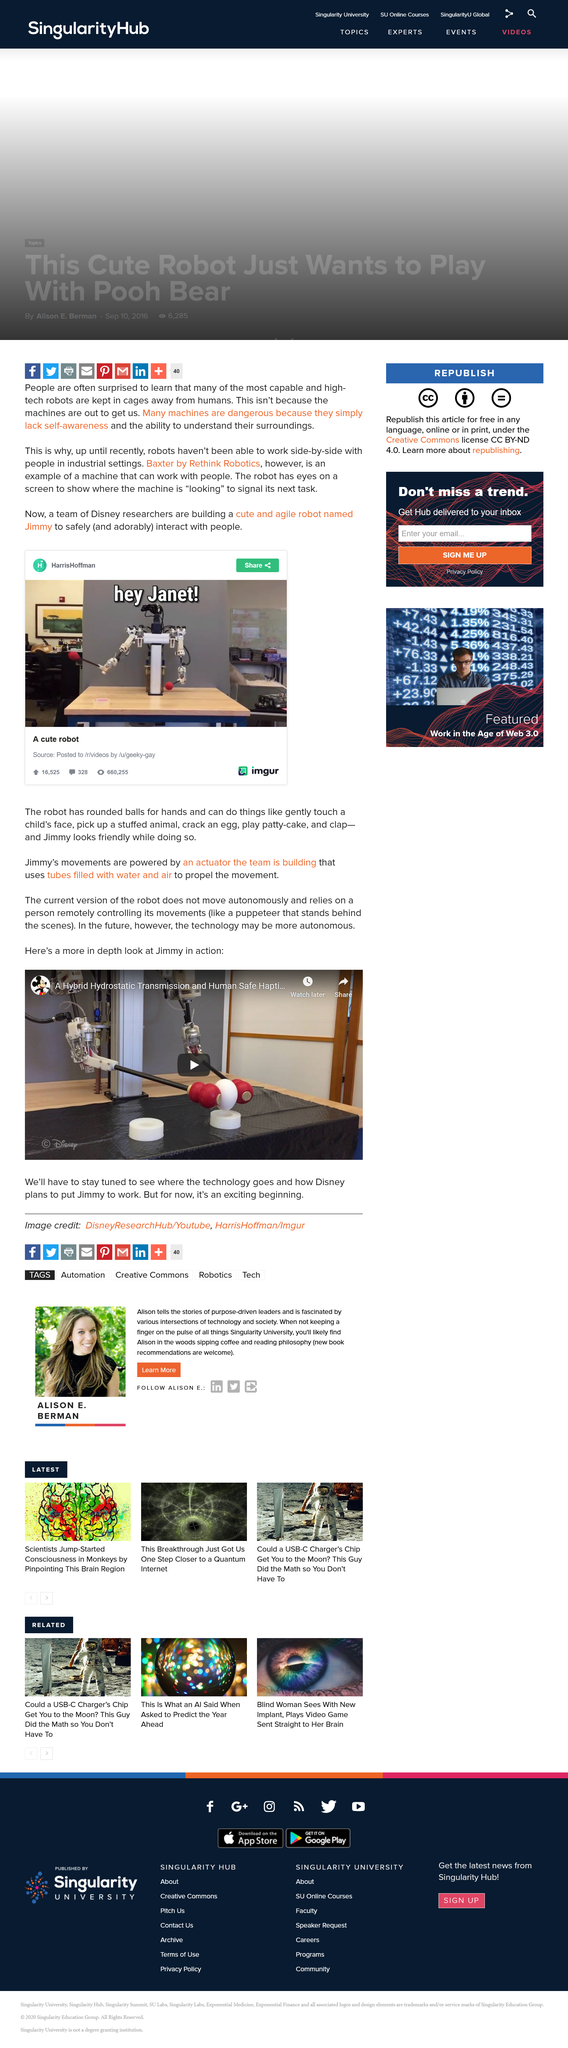Draw attention to some important aspects in this diagram. Yes, Disney is building a robot. Machines can be dangerous because they lack self-awareness and are therefore unable to fully comprehend the potential consequences of their actions. The robot featured in the image is named Jimmy. 